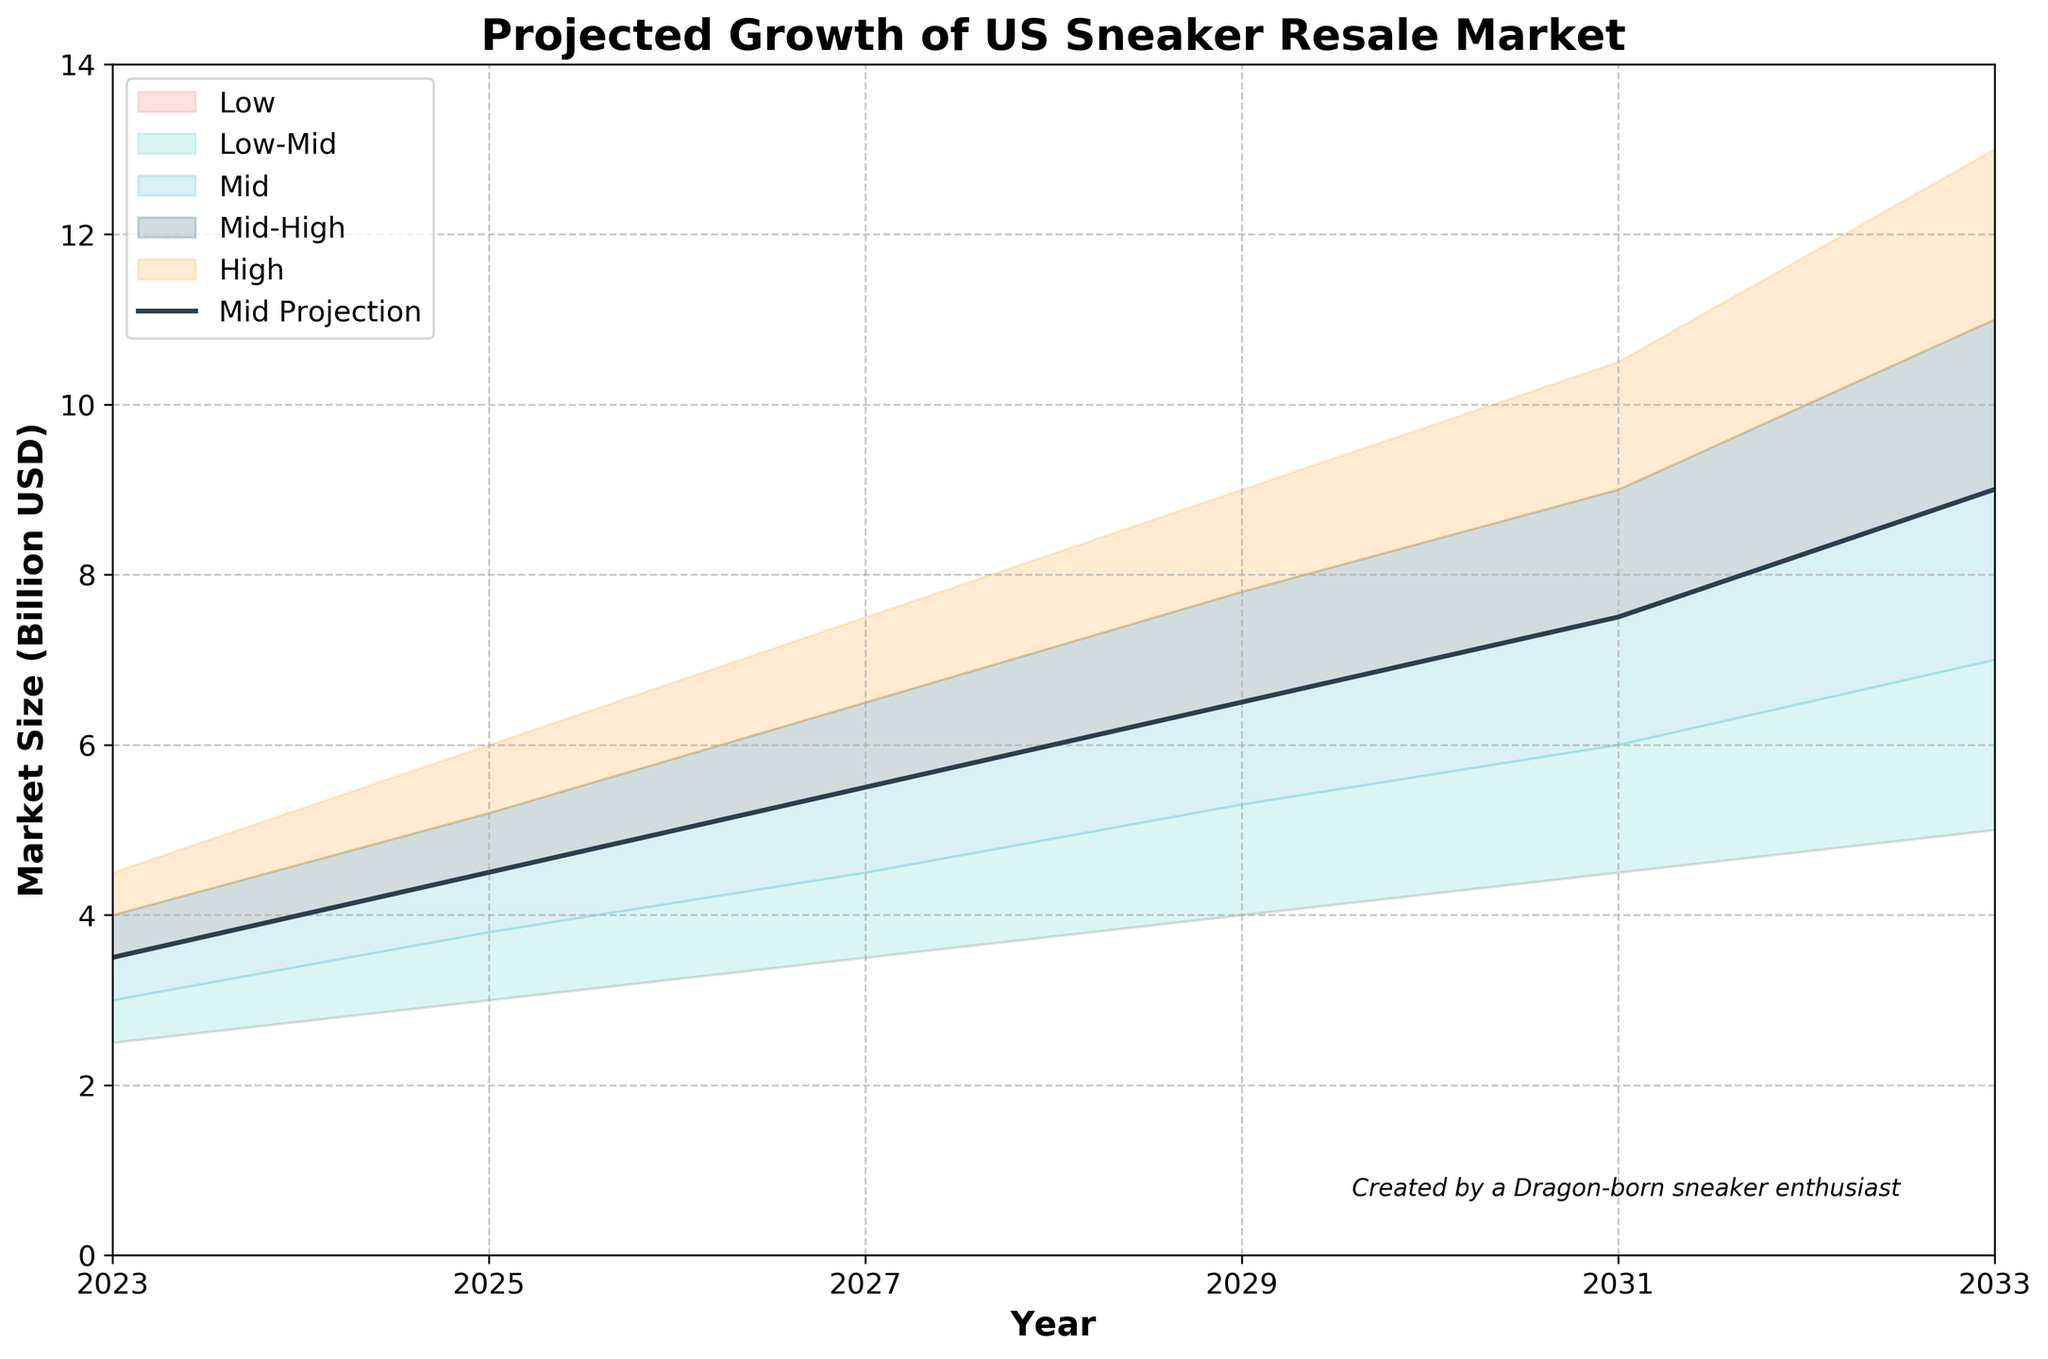what is the title of the chart? The title is usually displayed at the top of the chart. In this case, it's labeled directly at the top.
Answer: Projected Growth of US Sneaker Resale Market what year does the data start from? The starting point can be identified on the x-axis, which marks the beginning year on the extreme left.
Answer: 2023 What is the highest market size projected for 2033? To find this information, look at the 'High' projection in the year 2033 on the chart.
Answer: 13 Billion USD What is the projected mid-range market size for 2025? Locate the value for 'Mid' in the year 2025 on the chart.
Answer: 4.5 Billion USD How does the market size in 2027 compare between Mid and High projections? Compare the two values for 'Mid' and 'High' projections for the year 2027 on the chart.
Answer: Mid: 5.5 Billion USD, High: 7.5 Billion USD What is the range between Mid-High and Low projections in 2029? Determine the values for 'Mid-High' and 'Low' projections for 2029 and calculate the difference between them. Range = Mid-High - Low
Answer: 7.8 - 4 = 3.8 Billion USD How much is the projected market size expected to increase from 2023 to 2033 according to the Mid projection? Compare the 'Mid' projection values for 2023 and 2033, and then calculate the difference. Increase = Mid(2033) - Mid(2023)
Answer: 9 - 3.5 = 5.5 Billion USD what color is used for the Low-Mid projection? Each projection is color-coded. Identify the color associated with 'Low-Mid'.
Answer: It's light teal What is the difference between the Low and High projections in 2031? Fetch the values for 'Low' and 'High' in the year 2031 and compute the difference. Difference = High - Low
Answer: 10.5 - 4.5 = 6 Billion USD What trend do you see in the 'Mid' projection from 2023 to 2033? Observe the 'Mid' values over the years and describe the pattern or trend.
Answer: Increasing trend 